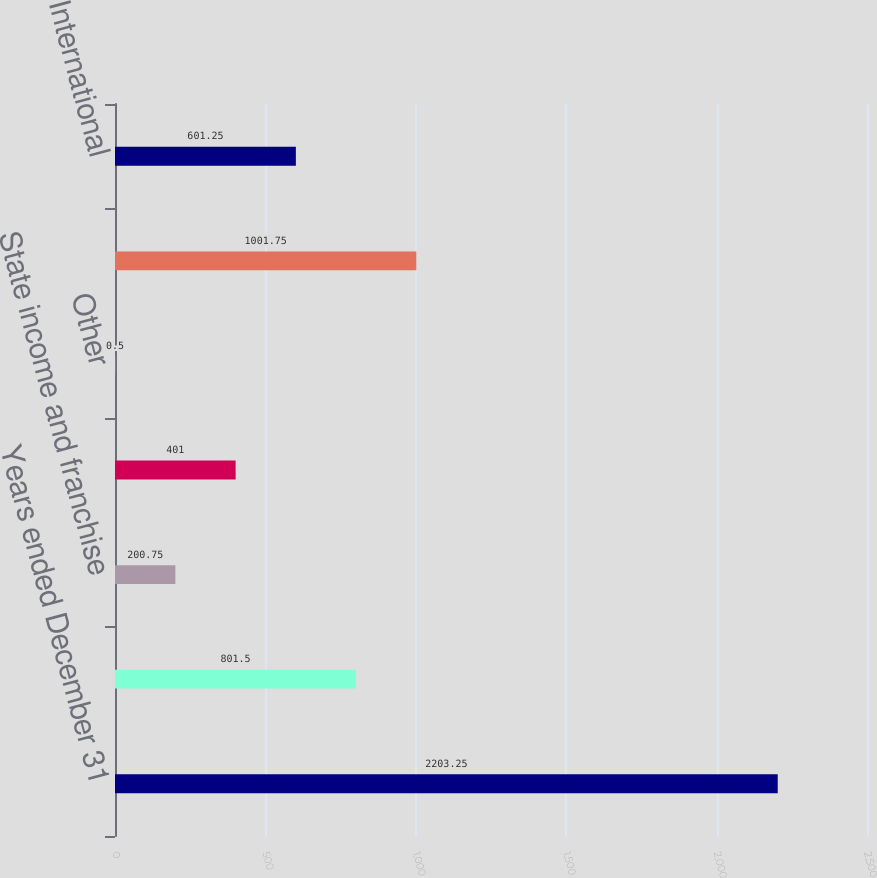Convert chart to OTSL. <chart><loc_0><loc_0><loc_500><loc_500><bar_chart><fcel>Years ended December 31<fcel>Provision at US federal<fcel>State income and franchise<fcel>International income tax rate<fcel>Other<fcel>United States<fcel>International<nl><fcel>2203.25<fcel>801.5<fcel>200.75<fcel>401<fcel>0.5<fcel>1001.75<fcel>601.25<nl></chart> 